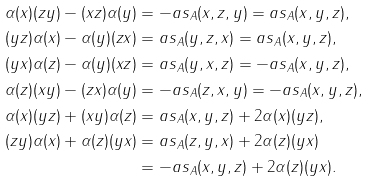Convert formula to latex. <formula><loc_0><loc_0><loc_500><loc_500>\alpha ( x ) ( z y ) - ( x z ) \alpha ( y ) & = - a s _ { A } ( x , z , y ) = a s _ { A } ( x , y , z ) , \\ ( y z ) \alpha ( x ) - \alpha ( y ) ( z x ) & = a s _ { A } ( y , z , x ) = a s _ { A } ( x , y , z ) , \\ ( y x ) \alpha ( z ) - \alpha ( y ) ( x z ) & = a s _ { A } ( y , x , z ) = - a s _ { A } ( x , y , z ) , \\ \alpha ( z ) ( x y ) - ( z x ) \alpha ( y ) & = - a s _ { A } ( z , x , y ) = - a s _ { A } ( x , y , z ) , \\ \alpha ( x ) ( y z ) + ( x y ) \alpha ( z ) & = a s _ { A } ( x , y , z ) + 2 \alpha ( x ) ( y z ) , \\ ( z y ) \alpha ( x ) + \alpha ( z ) ( y x ) & = a s _ { A } ( z , y , x ) + 2 \alpha ( z ) ( y x ) \\ & = - a s _ { A } ( x , y , z ) + 2 \alpha ( z ) ( y x ) .</formula> 